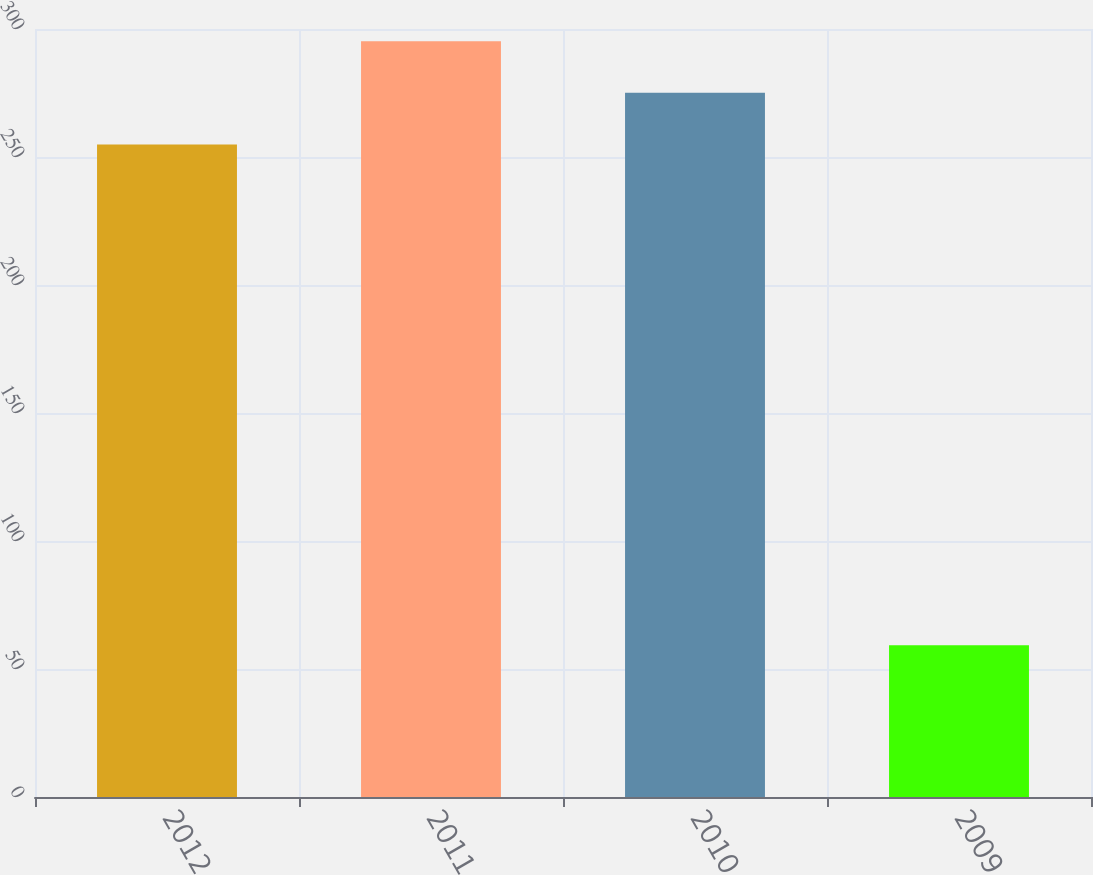Convert chart. <chart><loc_0><loc_0><loc_500><loc_500><bar_chart><fcel>2012<fcel>2011<fcel>2010<fcel>2009<nl><fcel>254.9<fcel>295.26<fcel>275.08<fcel>59.3<nl></chart> 